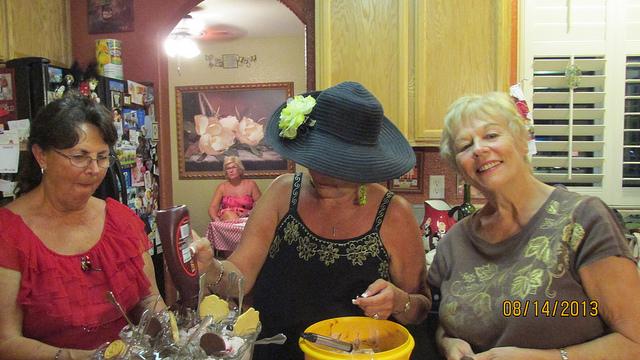What are these woman making?
Be succinct. Sundaes. What is on the side of the woman's hat?
Concise answer only. Flower. How many people are cooking?
Concise answer only. 3. What is in the yellow bucket?
Be succinct. Ice cream. Does this woman have on a necklace?
Keep it brief. Yes. Is the woman wearing glasses?
Concise answer only. Yes. How many people are in the photo?
Quick response, please. 4. How many people are wearing hats?
Quick response, please. 1. What are the women eating?
Short answer required. Nothing. 